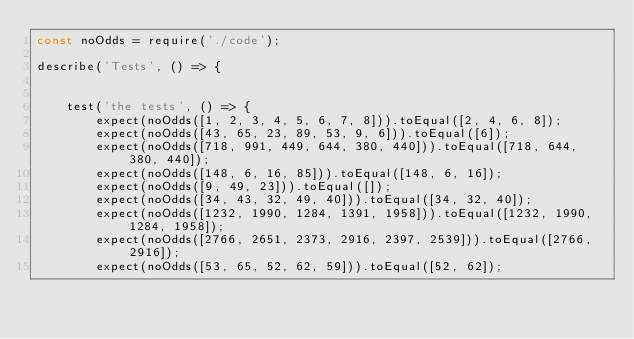<code> <loc_0><loc_0><loc_500><loc_500><_JavaScript_>const noOdds = require('./code');

describe('Tests', () => {
    
    
    test('the tests', () => {
        expect(noOdds([1, 2, 3, 4, 5, 6, 7, 8])).toEqual([2, 4, 6, 8]);
        expect(noOdds([43, 65, 23, 89, 53, 9, 6])).toEqual([6]);
        expect(noOdds([718, 991, 449, 644, 380, 440])).toEqual([718, 644, 380, 440]);
        expect(noOdds([148, 6, 16, 85])).toEqual([148, 6, 16]);
        expect(noOdds([9, 49, 23])).toEqual([]);
        expect(noOdds([34, 43, 32, 49, 40])).toEqual([34, 32, 40]);
        expect(noOdds([1232, 1990, 1284, 1391, 1958])).toEqual([1232, 1990, 1284, 1958]);
        expect(noOdds([2766, 2651, 2373, 2916, 2397, 2539])).toEqual([2766, 2916]);
        expect(noOdds([53, 65, 52, 62, 59])).toEqual([52, 62]);</code> 